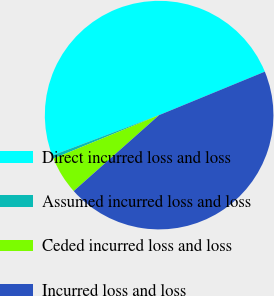<chart> <loc_0><loc_0><loc_500><loc_500><pie_chart><fcel>Direct incurred loss and loss<fcel>Assumed incurred loss and loss<fcel>Ceded incurred loss and loss<fcel>Incurred loss and loss<nl><fcel>49.54%<fcel>0.46%<fcel>5.36%<fcel>44.64%<nl></chart> 